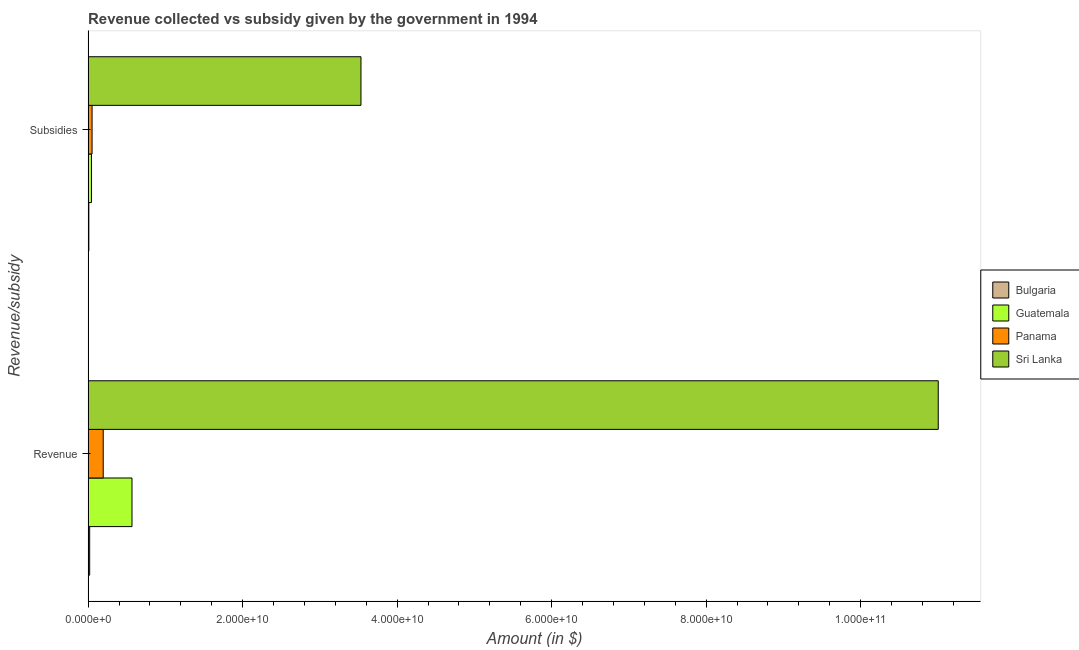How many groups of bars are there?
Offer a terse response. 2. Are the number of bars per tick equal to the number of legend labels?
Provide a short and direct response. Yes. Are the number of bars on each tick of the Y-axis equal?
Keep it short and to the point. Yes. How many bars are there on the 2nd tick from the top?
Provide a short and direct response. 4. How many bars are there on the 2nd tick from the bottom?
Provide a succinct answer. 4. What is the label of the 2nd group of bars from the top?
Offer a very short reply. Revenue. What is the amount of subsidies given in Sri Lanka?
Your answer should be very brief. 3.53e+1. Across all countries, what is the maximum amount of subsidies given?
Give a very brief answer. 3.53e+1. Across all countries, what is the minimum amount of subsidies given?
Your response must be concise. 9.74e+07. In which country was the amount of revenue collected maximum?
Give a very brief answer. Sri Lanka. In which country was the amount of subsidies given minimum?
Your response must be concise. Bulgaria. What is the total amount of revenue collected in the graph?
Provide a succinct answer. 1.18e+11. What is the difference between the amount of subsidies given in Bulgaria and that in Panama?
Your response must be concise. -4.18e+08. What is the difference between the amount of subsidies given in Sri Lanka and the amount of revenue collected in Guatemala?
Provide a succinct answer. 2.96e+1. What is the average amount of revenue collected per country?
Provide a succinct answer. 2.95e+1. What is the difference between the amount of revenue collected and amount of subsidies given in Bulgaria?
Provide a succinct answer. 1.07e+08. What is the ratio of the amount of subsidies given in Panama to that in Guatemala?
Provide a succinct answer. 1.18. Is the amount of revenue collected in Guatemala less than that in Panama?
Your response must be concise. No. What does the 2nd bar from the top in Revenue represents?
Your answer should be compact. Panama. Are all the bars in the graph horizontal?
Give a very brief answer. Yes. How many countries are there in the graph?
Your answer should be very brief. 4. Are the values on the major ticks of X-axis written in scientific E-notation?
Give a very brief answer. Yes. Does the graph contain any zero values?
Your response must be concise. No. Where does the legend appear in the graph?
Offer a terse response. Center right. How many legend labels are there?
Provide a succinct answer. 4. How are the legend labels stacked?
Keep it short and to the point. Vertical. What is the title of the graph?
Make the answer very short. Revenue collected vs subsidy given by the government in 1994. What is the label or title of the X-axis?
Ensure brevity in your answer.  Amount (in $). What is the label or title of the Y-axis?
Your answer should be compact. Revenue/subsidy. What is the Amount (in $) of Bulgaria in Revenue?
Offer a very short reply. 2.05e+08. What is the Amount (in $) in Guatemala in Revenue?
Provide a short and direct response. 5.68e+09. What is the Amount (in $) of Panama in Revenue?
Your response must be concise. 1.96e+09. What is the Amount (in $) in Sri Lanka in Revenue?
Your answer should be very brief. 1.10e+11. What is the Amount (in $) in Bulgaria in Subsidies?
Your answer should be compact. 9.74e+07. What is the Amount (in $) in Guatemala in Subsidies?
Your answer should be very brief. 4.37e+08. What is the Amount (in $) in Panama in Subsidies?
Give a very brief answer. 5.15e+08. What is the Amount (in $) of Sri Lanka in Subsidies?
Make the answer very short. 3.53e+1. Across all Revenue/subsidy, what is the maximum Amount (in $) of Bulgaria?
Provide a short and direct response. 2.05e+08. Across all Revenue/subsidy, what is the maximum Amount (in $) of Guatemala?
Ensure brevity in your answer.  5.68e+09. Across all Revenue/subsidy, what is the maximum Amount (in $) of Panama?
Ensure brevity in your answer.  1.96e+09. Across all Revenue/subsidy, what is the maximum Amount (in $) in Sri Lanka?
Your answer should be very brief. 1.10e+11. Across all Revenue/subsidy, what is the minimum Amount (in $) in Bulgaria?
Your answer should be very brief. 9.74e+07. Across all Revenue/subsidy, what is the minimum Amount (in $) of Guatemala?
Your answer should be compact. 4.37e+08. Across all Revenue/subsidy, what is the minimum Amount (in $) of Panama?
Keep it short and to the point. 5.15e+08. Across all Revenue/subsidy, what is the minimum Amount (in $) in Sri Lanka?
Provide a short and direct response. 3.53e+1. What is the total Amount (in $) of Bulgaria in the graph?
Provide a short and direct response. 3.02e+08. What is the total Amount (in $) in Guatemala in the graph?
Offer a very short reply. 6.12e+09. What is the total Amount (in $) in Panama in the graph?
Make the answer very short. 2.47e+09. What is the total Amount (in $) in Sri Lanka in the graph?
Offer a terse response. 1.45e+11. What is the difference between the Amount (in $) in Bulgaria in Revenue and that in Subsidies?
Provide a short and direct response. 1.07e+08. What is the difference between the Amount (in $) in Guatemala in Revenue and that in Subsidies?
Make the answer very short. 5.24e+09. What is the difference between the Amount (in $) of Panama in Revenue and that in Subsidies?
Ensure brevity in your answer.  1.44e+09. What is the difference between the Amount (in $) of Sri Lanka in Revenue and that in Subsidies?
Provide a succinct answer. 7.47e+1. What is the difference between the Amount (in $) in Bulgaria in Revenue and the Amount (in $) in Guatemala in Subsidies?
Ensure brevity in your answer.  -2.32e+08. What is the difference between the Amount (in $) in Bulgaria in Revenue and the Amount (in $) in Panama in Subsidies?
Your response must be concise. -3.11e+08. What is the difference between the Amount (in $) in Bulgaria in Revenue and the Amount (in $) in Sri Lanka in Subsidies?
Make the answer very short. -3.51e+1. What is the difference between the Amount (in $) in Guatemala in Revenue and the Amount (in $) in Panama in Subsidies?
Offer a very short reply. 5.17e+09. What is the difference between the Amount (in $) in Guatemala in Revenue and the Amount (in $) in Sri Lanka in Subsidies?
Your response must be concise. -2.96e+1. What is the difference between the Amount (in $) of Panama in Revenue and the Amount (in $) of Sri Lanka in Subsidies?
Your response must be concise. -3.34e+1. What is the average Amount (in $) of Bulgaria per Revenue/subsidy?
Offer a very short reply. 1.51e+08. What is the average Amount (in $) of Guatemala per Revenue/subsidy?
Provide a succinct answer. 3.06e+09. What is the average Amount (in $) of Panama per Revenue/subsidy?
Offer a very short reply. 1.24e+09. What is the average Amount (in $) in Sri Lanka per Revenue/subsidy?
Provide a short and direct response. 7.27e+1. What is the difference between the Amount (in $) of Bulgaria and Amount (in $) of Guatemala in Revenue?
Your response must be concise. -5.48e+09. What is the difference between the Amount (in $) in Bulgaria and Amount (in $) in Panama in Revenue?
Your answer should be very brief. -1.75e+09. What is the difference between the Amount (in $) in Bulgaria and Amount (in $) in Sri Lanka in Revenue?
Offer a terse response. -1.10e+11. What is the difference between the Amount (in $) of Guatemala and Amount (in $) of Panama in Revenue?
Ensure brevity in your answer.  3.72e+09. What is the difference between the Amount (in $) in Guatemala and Amount (in $) in Sri Lanka in Revenue?
Ensure brevity in your answer.  -1.04e+11. What is the difference between the Amount (in $) in Panama and Amount (in $) in Sri Lanka in Revenue?
Your answer should be very brief. -1.08e+11. What is the difference between the Amount (in $) in Bulgaria and Amount (in $) in Guatemala in Subsidies?
Make the answer very short. -3.39e+08. What is the difference between the Amount (in $) of Bulgaria and Amount (in $) of Panama in Subsidies?
Provide a succinct answer. -4.18e+08. What is the difference between the Amount (in $) of Bulgaria and Amount (in $) of Sri Lanka in Subsidies?
Your answer should be compact. -3.52e+1. What is the difference between the Amount (in $) of Guatemala and Amount (in $) of Panama in Subsidies?
Your answer should be compact. -7.87e+07. What is the difference between the Amount (in $) in Guatemala and Amount (in $) in Sri Lanka in Subsidies?
Your answer should be very brief. -3.49e+1. What is the difference between the Amount (in $) in Panama and Amount (in $) in Sri Lanka in Subsidies?
Offer a very short reply. -3.48e+1. What is the ratio of the Amount (in $) in Bulgaria in Revenue to that in Subsidies?
Ensure brevity in your answer.  2.1. What is the ratio of the Amount (in $) in Guatemala in Revenue to that in Subsidies?
Provide a short and direct response. 13.01. What is the ratio of the Amount (in $) of Panama in Revenue to that in Subsidies?
Offer a terse response. 3.8. What is the ratio of the Amount (in $) in Sri Lanka in Revenue to that in Subsidies?
Give a very brief answer. 3.12. What is the difference between the highest and the second highest Amount (in $) of Bulgaria?
Your response must be concise. 1.07e+08. What is the difference between the highest and the second highest Amount (in $) of Guatemala?
Give a very brief answer. 5.24e+09. What is the difference between the highest and the second highest Amount (in $) of Panama?
Your answer should be very brief. 1.44e+09. What is the difference between the highest and the second highest Amount (in $) in Sri Lanka?
Offer a terse response. 7.47e+1. What is the difference between the highest and the lowest Amount (in $) in Bulgaria?
Give a very brief answer. 1.07e+08. What is the difference between the highest and the lowest Amount (in $) of Guatemala?
Provide a succinct answer. 5.24e+09. What is the difference between the highest and the lowest Amount (in $) in Panama?
Your answer should be very brief. 1.44e+09. What is the difference between the highest and the lowest Amount (in $) in Sri Lanka?
Provide a succinct answer. 7.47e+1. 